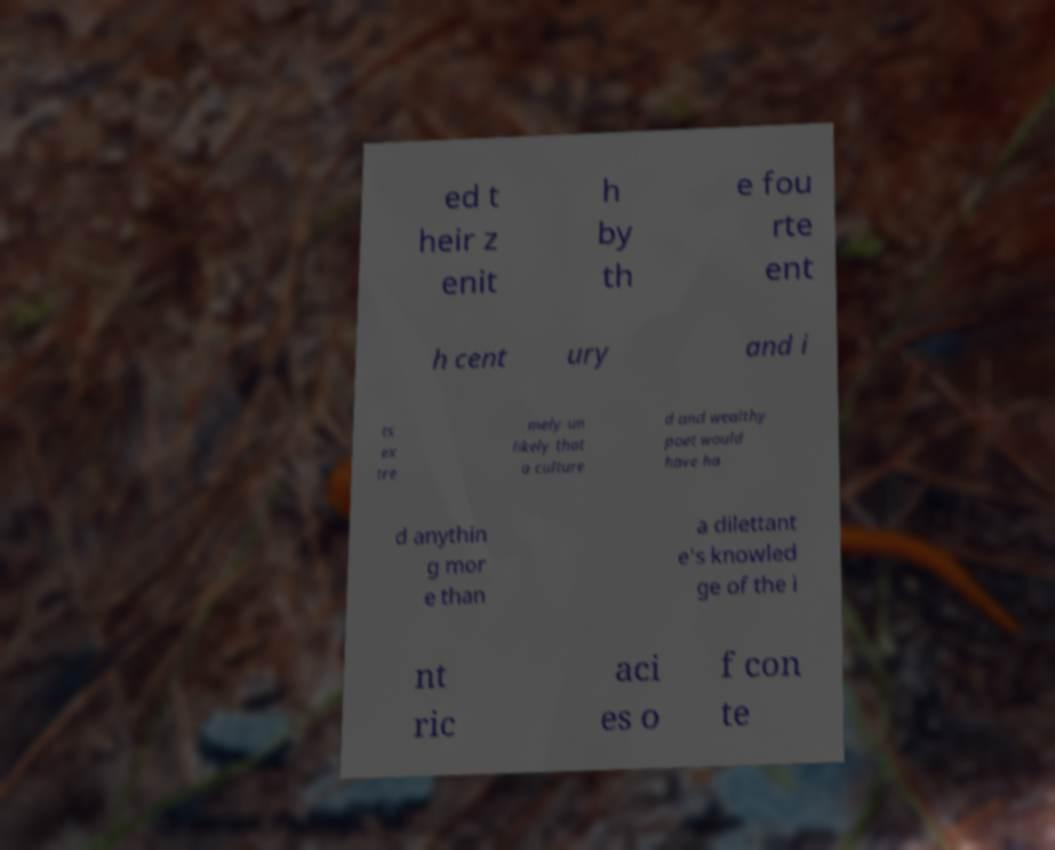Please identify and transcribe the text found in this image. ed t heir z enit h by th e fou rte ent h cent ury and i ts ex tre mely un likely that a culture d and wealthy poet would have ha d anythin g mor e than a dilettant e's knowled ge of the i nt ric aci es o f con te 